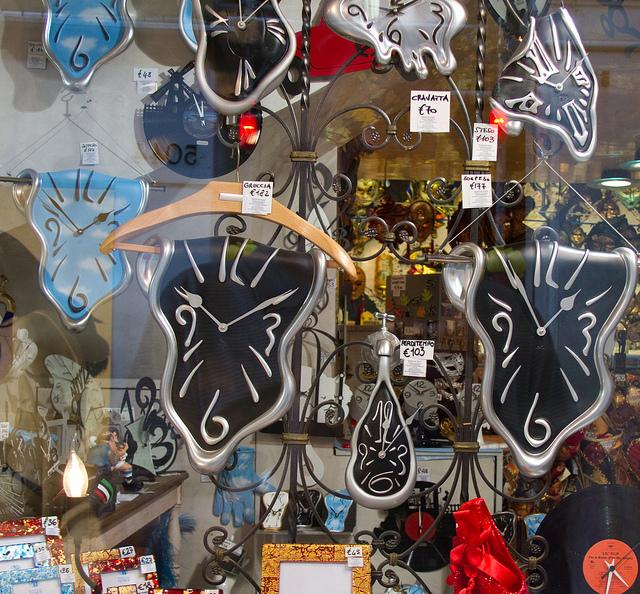Do all clocks show the same time?
Keep it brief. No. What is the clock hanging on?
Quick response, please. Hanger. What artist are the items taking their style from?
Short answer required. Dali. 